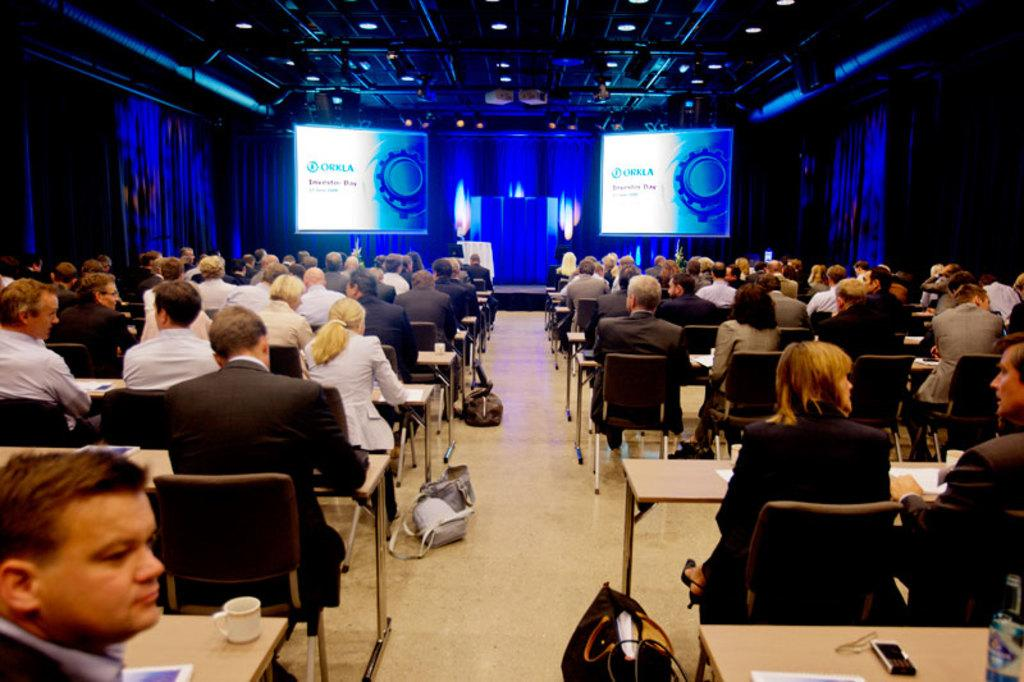What is happening in the center of the image? There are many people sitting on chairs in the center of the image. What can be seen in the background of the image? There are projector screens in the background of the image. What type of rice is being served on the projector screens in the image? There is no rice present in the image, and the projector screens are not serving any food. 